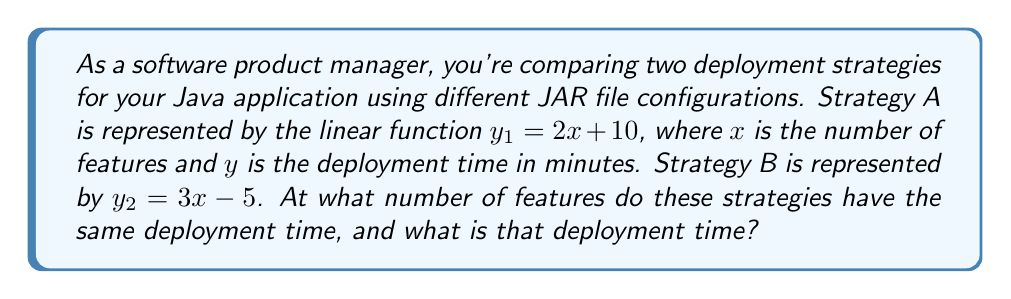Solve this math problem. To find the intersection point of these two linear functions, we need to solve the equation where $y_1 = y_2$:

$$2x + 10 = 3x - 5$$

Let's solve this step-by-step:

1) Subtract $2x$ from both sides:
   $$10 = x - 5$$

2) Add 5 to both sides:
   $$15 = x$$

So, the strategies intersect when $x = 15$ features.

To find the deployment time at this intersection, we can substitute $x = 15$ into either of the original equations. Let's use Strategy A:

$$y_1 = 2(15) + 10 = 30 + 10 = 40$$

Therefore, the deployment time at the intersection point is 40 minutes.

We can verify this with Strategy B:
$$y_2 = 3(15) - 5 = 45 - 5 = 40$$

This confirms our result.
Answer: The strategies have the same deployment time when there are 15 features, and the deployment time at this point is 40 minutes. 